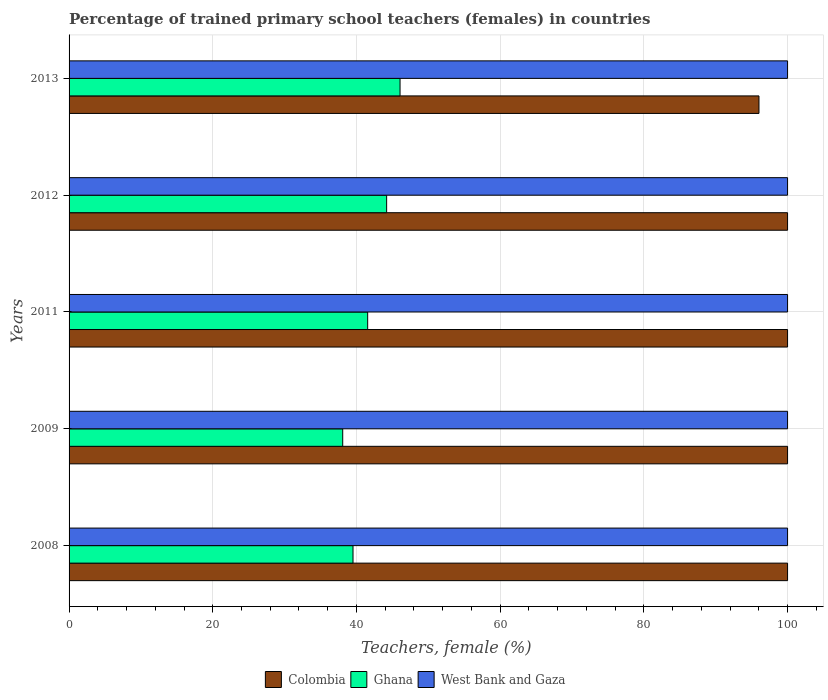How many different coloured bars are there?
Offer a very short reply. 3. How many bars are there on the 2nd tick from the top?
Give a very brief answer. 3. In how many cases, is the number of bars for a given year not equal to the number of legend labels?
Your answer should be compact. 0. What is the percentage of trained primary school teachers (females) in West Bank and Gaza in 2013?
Your answer should be compact. 100. Across all years, what is the maximum percentage of trained primary school teachers (females) in Colombia?
Keep it short and to the point. 100. Across all years, what is the minimum percentage of trained primary school teachers (females) in Ghana?
Provide a short and direct response. 38.09. In which year was the percentage of trained primary school teachers (females) in Colombia maximum?
Keep it short and to the point. 2008. What is the difference between the percentage of trained primary school teachers (females) in West Bank and Gaza in 2012 and that in 2013?
Make the answer very short. 0. What is the difference between the percentage of trained primary school teachers (females) in Colombia in 2011 and the percentage of trained primary school teachers (females) in West Bank and Gaza in 2008?
Keep it short and to the point. 0. What is the average percentage of trained primary school teachers (females) in Colombia per year?
Your response must be concise. 99.2. In the year 2012, what is the difference between the percentage of trained primary school teachers (females) in Ghana and percentage of trained primary school teachers (females) in Colombia?
Provide a short and direct response. -55.8. In how many years, is the percentage of trained primary school teachers (females) in Colombia greater than 72 %?
Offer a very short reply. 5. What is the ratio of the percentage of trained primary school teachers (females) in Colombia in 2012 to that in 2013?
Provide a short and direct response. 1.04. What is the difference between the highest and the second highest percentage of trained primary school teachers (females) in West Bank and Gaza?
Your answer should be compact. 0. What is the difference between the highest and the lowest percentage of trained primary school teachers (females) in West Bank and Gaza?
Your answer should be compact. 0. Is the sum of the percentage of trained primary school teachers (females) in West Bank and Gaza in 2009 and 2013 greater than the maximum percentage of trained primary school teachers (females) in Colombia across all years?
Offer a very short reply. Yes. What does the 3rd bar from the top in 2013 represents?
Your answer should be very brief. Colombia. Is it the case that in every year, the sum of the percentage of trained primary school teachers (females) in Colombia and percentage of trained primary school teachers (females) in West Bank and Gaza is greater than the percentage of trained primary school teachers (females) in Ghana?
Your answer should be compact. Yes. How many bars are there?
Provide a short and direct response. 15. How many years are there in the graph?
Offer a very short reply. 5. What is the difference between two consecutive major ticks on the X-axis?
Provide a succinct answer. 20. Are the values on the major ticks of X-axis written in scientific E-notation?
Provide a short and direct response. No. Does the graph contain any zero values?
Make the answer very short. No. Does the graph contain grids?
Make the answer very short. Yes. How many legend labels are there?
Make the answer very short. 3. How are the legend labels stacked?
Your answer should be compact. Horizontal. What is the title of the graph?
Offer a very short reply. Percentage of trained primary school teachers (females) in countries. What is the label or title of the X-axis?
Offer a very short reply. Teachers, female (%). What is the Teachers, female (%) of Colombia in 2008?
Your response must be concise. 100. What is the Teachers, female (%) in Ghana in 2008?
Your response must be concise. 39.52. What is the Teachers, female (%) in Colombia in 2009?
Keep it short and to the point. 100. What is the Teachers, female (%) of Ghana in 2009?
Provide a short and direct response. 38.09. What is the Teachers, female (%) in West Bank and Gaza in 2009?
Offer a very short reply. 100. What is the Teachers, female (%) of Colombia in 2011?
Provide a succinct answer. 100. What is the Teachers, female (%) of Ghana in 2011?
Offer a terse response. 41.56. What is the Teachers, female (%) of West Bank and Gaza in 2011?
Your answer should be compact. 100. What is the Teachers, female (%) in Ghana in 2012?
Offer a very short reply. 44.2. What is the Teachers, female (%) of Colombia in 2013?
Your answer should be compact. 96.02. What is the Teachers, female (%) in Ghana in 2013?
Offer a very short reply. 46.06. What is the Teachers, female (%) of West Bank and Gaza in 2013?
Ensure brevity in your answer.  100. Across all years, what is the maximum Teachers, female (%) in Ghana?
Your answer should be very brief. 46.06. Across all years, what is the maximum Teachers, female (%) in West Bank and Gaza?
Offer a terse response. 100. Across all years, what is the minimum Teachers, female (%) in Colombia?
Provide a short and direct response. 96.02. Across all years, what is the minimum Teachers, female (%) in Ghana?
Provide a succinct answer. 38.09. Across all years, what is the minimum Teachers, female (%) of West Bank and Gaza?
Offer a very short reply. 100. What is the total Teachers, female (%) of Colombia in the graph?
Provide a short and direct response. 496.02. What is the total Teachers, female (%) of Ghana in the graph?
Offer a very short reply. 209.43. What is the total Teachers, female (%) in West Bank and Gaza in the graph?
Offer a terse response. 500. What is the difference between the Teachers, female (%) of Colombia in 2008 and that in 2009?
Offer a terse response. 0. What is the difference between the Teachers, female (%) in Ghana in 2008 and that in 2009?
Ensure brevity in your answer.  1.43. What is the difference between the Teachers, female (%) of West Bank and Gaza in 2008 and that in 2009?
Ensure brevity in your answer.  0. What is the difference between the Teachers, female (%) of Ghana in 2008 and that in 2011?
Provide a succinct answer. -2.04. What is the difference between the Teachers, female (%) of Ghana in 2008 and that in 2012?
Your answer should be very brief. -4.68. What is the difference between the Teachers, female (%) of Colombia in 2008 and that in 2013?
Make the answer very short. 3.98. What is the difference between the Teachers, female (%) in Ghana in 2008 and that in 2013?
Your answer should be very brief. -6.55. What is the difference between the Teachers, female (%) of West Bank and Gaza in 2008 and that in 2013?
Keep it short and to the point. 0. What is the difference between the Teachers, female (%) of Colombia in 2009 and that in 2011?
Your answer should be very brief. 0. What is the difference between the Teachers, female (%) of Ghana in 2009 and that in 2011?
Offer a terse response. -3.47. What is the difference between the Teachers, female (%) of Colombia in 2009 and that in 2012?
Keep it short and to the point. 0. What is the difference between the Teachers, female (%) in Ghana in 2009 and that in 2012?
Give a very brief answer. -6.11. What is the difference between the Teachers, female (%) of Colombia in 2009 and that in 2013?
Offer a terse response. 3.98. What is the difference between the Teachers, female (%) of Ghana in 2009 and that in 2013?
Offer a very short reply. -7.98. What is the difference between the Teachers, female (%) of Ghana in 2011 and that in 2012?
Provide a short and direct response. -2.64. What is the difference between the Teachers, female (%) in West Bank and Gaza in 2011 and that in 2012?
Ensure brevity in your answer.  0. What is the difference between the Teachers, female (%) of Colombia in 2011 and that in 2013?
Give a very brief answer. 3.98. What is the difference between the Teachers, female (%) in Ghana in 2011 and that in 2013?
Provide a short and direct response. -4.5. What is the difference between the Teachers, female (%) of West Bank and Gaza in 2011 and that in 2013?
Ensure brevity in your answer.  0. What is the difference between the Teachers, female (%) in Colombia in 2012 and that in 2013?
Provide a succinct answer. 3.98. What is the difference between the Teachers, female (%) of Ghana in 2012 and that in 2013?
Give a very brief answer. -1.87. What is the difference between the Teachers, female (%) in Colombia in 2008 and the Teachers, female (%) in Ghana in 2009?
Your answer should be very brief. 61.91. What is the difference between the Teachers, female (%) of Ghana in 2008 and the Teachers, female (%) of West Bank and Gaza in 2009?
Give a very brief answer. -60.48. What is the difference between the Teachers, female (%) in Colombia in 2008 and the Teachers, female (%) in Ghana in 2011?
Your response must be concise. 58.44. What is the difference between the Teachers, female (%) of Ghana in 2008 and the Teachers, female (%) of West Bank and Gaza in 2011?
Offer a terse response. -60.48. What is the difference between the Teachers, female (%) of Colombia in 2008 and the Teachers, female (%) of Ghana in 2012?
Provide a succinct answer. 55.8. What is the difference between the Teachers, female (%) of Ghana in 2008 and the Teachers, female (%) of West Bank and Gaza in 2012?
Your answer should be compact. -60.48. What is the difference between the Teachers, female (%) in Colombia in 2008 and the Teachers, female (%) in Ghana in 2013?
Your response must be concise. 53.94. What is the difference between the Teachers, female (%) of Ghana in 2008 and the Teachers, female (%) of West Bank and Gaza in 2013?
Give a very brief answer. -60.48. What is the difference between the Teachers, female (%) in Colombia in 2009 and the Teachers, female (%) in Ghana in 2011?
Ensure brevity in your answer.  58.44. What is the difference between the Teachers, female (%) of Colombia in 2009 and the Teachers, female (%) of West Bank and Gaza in 2011?
Ensure brevity in your answer.  0. What is the difference between the Teachers, female (%) in Ghana in 2009 and the Teachers, female (%) in West Bank and Gaza in 2011?
Your response must be concise. -61.91. What is the difference between the Teachers, female (%) in Colombia in 2009 and the Teachers, female (%) in Ghana in 2012?
Your answer should be very brief. 55.8. What is the difference between the Teachers, female (%) in Colombia in 2009 and the Teachers, female (%) in West Bank and Gaza in 2012?
Your answer should be very brief. 0. What is the difference between the Teachers, female (%) in Ghana in 2009 and the Teachers, female (%) in West Bank and Gaza in 2012?
Your answer should be compact. -61.91. What is the difference between the Teachers, female (%) of Colombia in 2009 and the Teachers, female (%) of Ghana in 2013?
Keep it short and to the point. 53.94. What is the difference between the Teachers, female (%) of Ghana in 2009 and the Teachers, female (%) of West Bank and Gaza in 2013?
Provide a short and direct response. -61.91. What is the difference between the Teachers, female (%) in Colombia in 2011 and the Teachers, female (%) in Ghana in 2012?
Provide a succinct answer. 55.8. What is the difference between the Teachers, female (%) of Ghana in 2011 and the Teachers, female (%) of West Bank and Gaza in 2012?
Your answer should be compact. -58.44. What is the difference between the Teachers, female (%) of Colombia in 2011 and the Teachers, female (%) of Ghana in 2013?
Your answer should be very brief. 53.94. What is the difference between the Teachers, female (%) in Colombia in 2011 and the Teachers, female (%) in West Bank and Gaza in 2013?
Offer a very short reply. 0. What is the difference between the Teachers, female (%) of Ghana in 2011 and the Teachers, female (%) of West Bank and Gaza in 2013?
Offer a terse response. -58.44. What is the difference between the Teachers, female (%) of Colombia in 2012 and the Teachers, female (%) of Ghana in 2013?
Give a very brief answer. 53.94. What is the difference between the Teachers, female (%) in Colombia in 2012 and the Teachers, female (%) in West Bank and Gaza in 2013?
Offer a terse response. 0. What is the difference between the Teachers, female (%) of Ghana in 2012 and the Teachers, female (%) of West Bank and Gaza in 2013?
Your answer should be compact. -55.8. What is the average Teachers, female (%) in Colombia per year?
Offer a terse response. 99.2. What is the average Teachers, female (%) of Ghana per year?
Provide a succinct answer. 41.89. In the year 2008, what is the difference between the Teachers, female (%) in Colombia and Teachers, female (%) in Ghana?
Provide a succinct answer. 60.48. In the year 2008, what is the difference between the Teachers, female (%) of Colombia and Teachers, female (%) of West Bank and Gaza?
Keep it short and to the point. 0. In the year 2008, what is the difference between the Teachers, female (%) in Ghana and Teachers, female (%) in West Bank and Gaza?
Provide a succinct answer. -60.48. In the year 2009, what is the difference between the Teachers, female (%) of Colombia and Teachers, female (%) of Ghana?
Keep it short and to the point. 61.91. In the year 2009, what is the difference between the Teachers, female (%) of Colombia and Teachers, female (%) of West Bank and Gaza?
Provide a short and direct response. 0. In the year 2009, what is the difference between the Teachers, female (%) in Ghana and Teachers, female (%) in West Bank and Gaza?
Make the answer very short. -61.91. In the year 2011, what is the difference between the Teachers, female (%) of Colombia and Teachers, female (%) of Ghana?
Offer a very short reply. 58.44. In the year 2011, what is the difference between the Teachers, female (%) in Colombia and Teachers, female (%) in West Bank and Gaza?
Keep it short and to the point. 0. In the year 2011, what is the difference between the Teachers, female (%) in Ghana and Teachers, female (%) in West Bank and Gaza?
Your response must be concise. -58.44. In the year 2012, what is the difference between the Teachers, female (%) in Colombia and Teachers, female (%) in Ghana?
Make the answer very short. 55.8. In the year 2012, what is the difference between the Teachers, female (%) in Ghana and Teachers, female (%) in West Bank and Gaza?
Ensure brevity in your answer.  -55.8. In the year 2013, what is the difference between the Teachers, female (%) of Colombia and Teachers, female (%) of Ghana?
Keep it short and to the point. 49.95. In the year 2013, what is the difference between the Teachers, female (%) of Colombia and Teachers, female (%) of West Bank and Gaza?
Your response must be concise. -3.98. In the year 2013, what is the difference between the Teachers, female (%) in Ghana and Teachers, female (%) in West Bank and Gaza?
Your answer should be very brief. -53.94. What is the ratio of the Teachers, female (%) of Ghana in 2008 to that in 2009?
Make the answer very short. 1.04. What is the ratio of the Teachers, female (%) in West Bank and Gaza in 2008 to that in 2009?
Give a very brief answer. 1. What is the ratio of the Teachers, female (%) in Ghana in 2008 to that in 2011?
Give a very brief answer. 0.95. What is the ratio of the Teachers, female (%) in Colombia in 2008 to that in 2012?
Your answer should be compact. 1. What is the ratio of the Teachers, female (%) in Ghana in 2008 to that in 2012?
Your answer should be very brief. 0.89. What is the ratio of the Teachers, female (%) in Colombia in 2008 to that in 2013?
Provide a succinct answer. 1.04. What is the ratio of the Teachers, female (%) in Ghana in 2008 to that in 2013?
Keep it short and to the point. 0.86. What is the ratio of the Teachers, female (%) of West Bank and Gaza in 2008 to that in 2013?
Provide a succinct answer. 1. What is the ratio of the Teachers, female (%) of Ghana in 2009 to that in 2011?
Your answer should be very brief. 0.92. What is the ratio of the Teachers, female (%) of West Bank and Gaza in 2009 to that in 2011?
Make the answer very short. 1. What is the ratio of the Teachers, female (%) in Ghana in 2009 to that in 2012?
Offer a very short reply. 0.86. What is the ratio of the Teachers, female (%) in Colombia in 2009 to that in 2013?
Offer a terse response. 1.04. What is the ratio of the Teachers, female (%) of Ghana in 2009 to that in 2013?
Provide a succinct answer. 0.83. What is the ratio of the Teachers, female (%) in Colombia in 2011 to that in 2012?
Your answer should be very brief. 1. What is the ratio of the Teachers, female (%) in Ghana in 2011 to that in 2012?
Provide a short and direct response. 0.94. What is the ratio of the Teachers, female (%) in Colombia in 2011 to that in 2013?
Keep it short and to the point. 1.04. What is the ratio of the Teachers, female (%) in Ghana in 2011 to that in 2013?
Ensure brevity in your answer.  0.9. What is the ratio of the Teachers, female (%) of West Bank and Gaza in 2011 to that in 2013?
Your answer should be compact. 1. What is the ratio of the Teachers, female (%) of Colombia in 2012 to that in 2013?
Give a very brief answer. 1.04. What is the ratio of the Teachers, female (%) in Ghana in 2012 to that in 2013?
Your answer should be compact. 0.96. What is the ratio of the Teachers, female (%) in West Bank and Gaza in 2012 to that in 2013?
Offer a very short reply. 1. What is the difference between the highest and the second highest Teachers, female (%) in Ghana?
Offer a very short reply. 1.87. What is the difference between the highest and the lowest Teachers, female (%) in Colombia?
Provide a short and direct response. 3.98. What is the difference between the highest and the lowest Teachers, female (%) in Ghana?
Offer a very short reply. 7.98. 